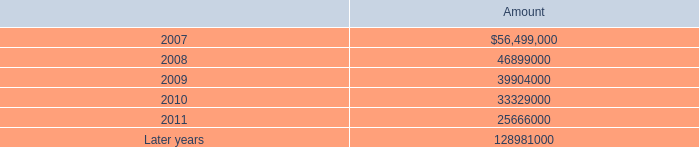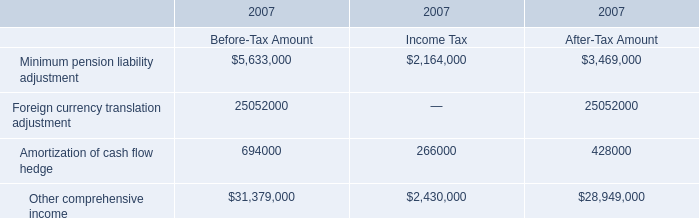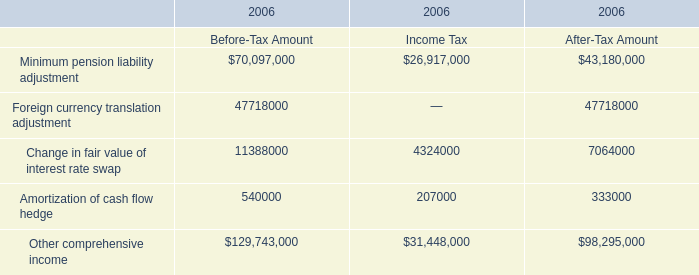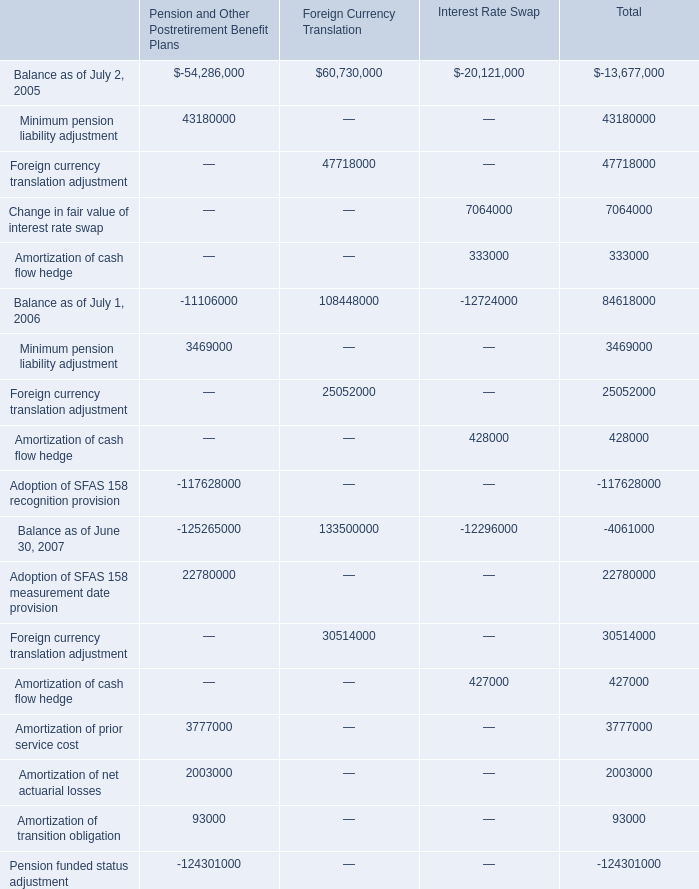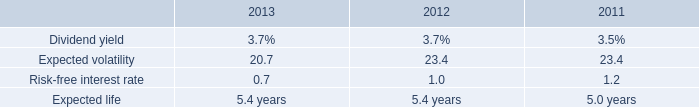What is the total amount of Balance as of July 1, 2006 of Interest Rate Swap, and Minimum pension liability adjustment of 2006 Income Tax ? 
Computations: (12724000.0 + 26917000.0)
Answer: 39641000.0. 